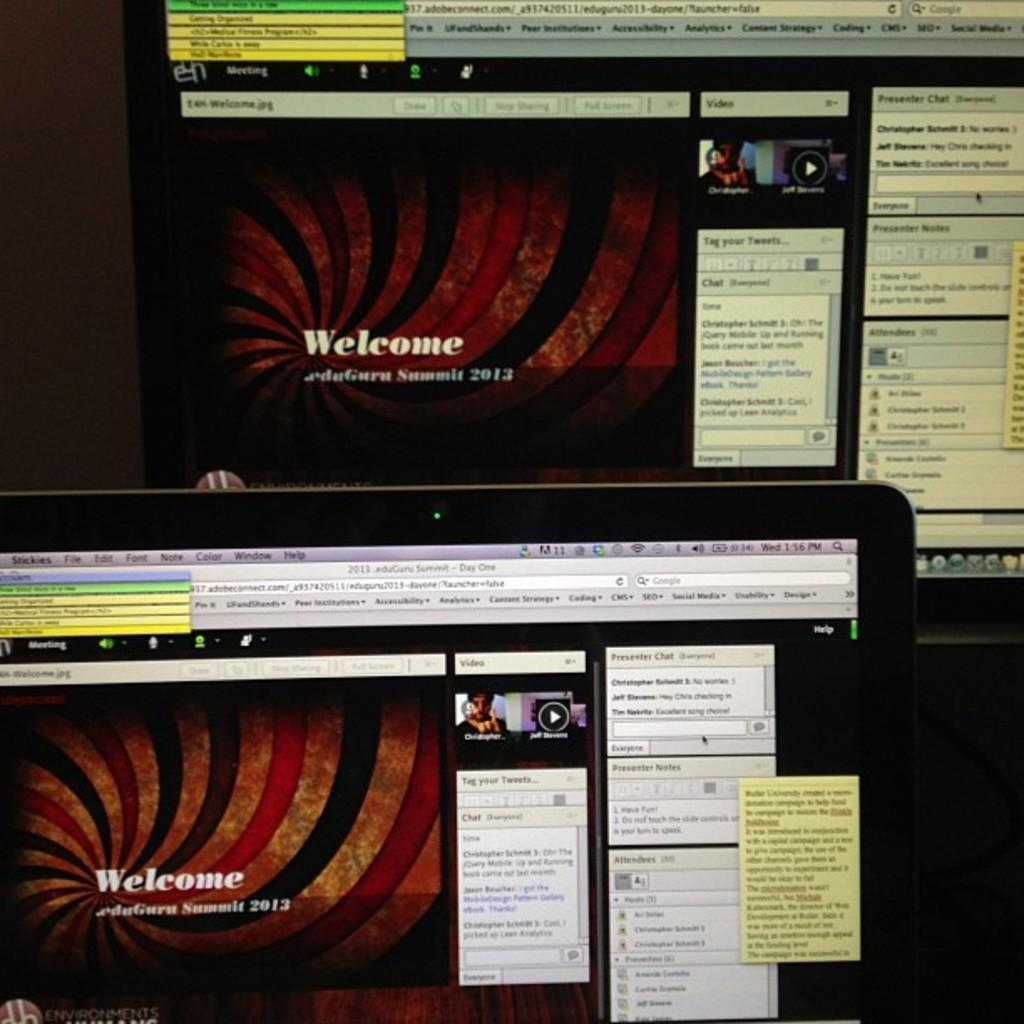<image>
Describe the image concisely. Two computer monitors with a red striped slide on them that says Welcome. 